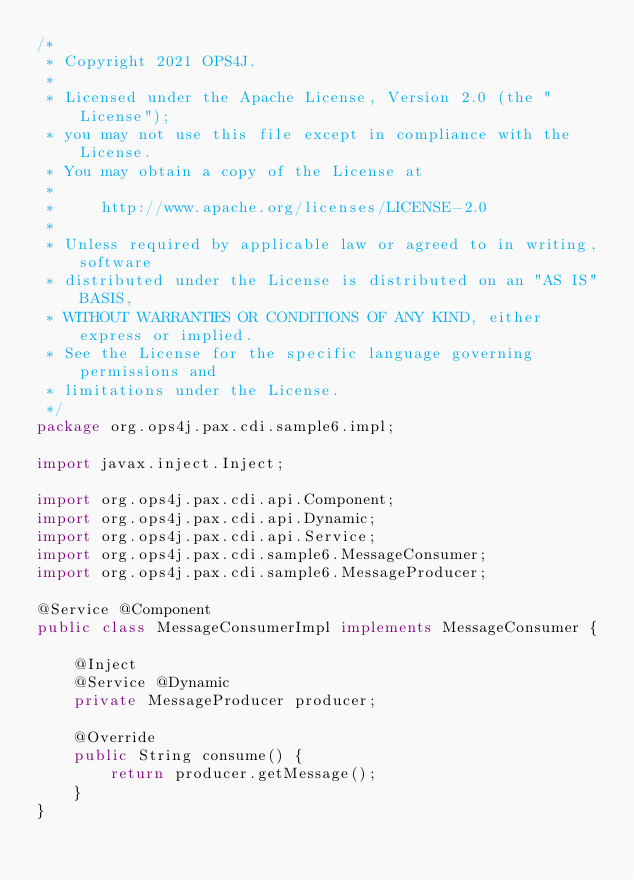Convert code to text. <code><loc_0><loc_0><loc_500><loc_500><_Java_>/*
 * Copyright 2021 OPS4J.
 *
 * Licensed under the Apache License, Version 2.0 (the "License");
 * you may not use this file except in compliance with the License.
 * You may obtain a copy of the License at
 *
 *     http://www.apache.org/licenses/LICENSE-2.0
 *
 * Unless required by applicable law or agreed to in writing, software
 * distributed under the License is distributed on an "AS IS" BASIS,
 * WITHOUT WARRANTIES OR CONDITIONS OF ANY KIND, either express or implied.
 * See the License for the specific language governing permissions and
 * limitations under the License.
 */
package org.ops4j.pax.cdi.sample6.impl;

import javax.inject.Inject;

import org.ops4j.pax.cdi.api.Component;
import org.ops4j.pax.cdi.api.Dynamic;
import org.ops4j.pax.cdi.api.Service;
import org.ops4j.pax.cdi.sample6.MessageConsumer;
import org.ops4j.pax.cdi.sample6.MessageProducer;

@Service @Component
public class MessageConsumerImpl implements MessageConsumer {

    @Inject
    @Service @Dynamic
    private MessageProducer producer;

    @Override
    public String consume() {
        return producer.getMessage();
    }
}
</code> 